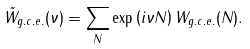Convert formula to latex. <formula><loc_0><loc_0><loc_500><loc_500>\tilde { W } _ { g . c . e . } ( \nu ) = \sum _ { N } \exp \left ( i \nu N \right ) W _ { g . c . e . } ( N ) .</formula> 